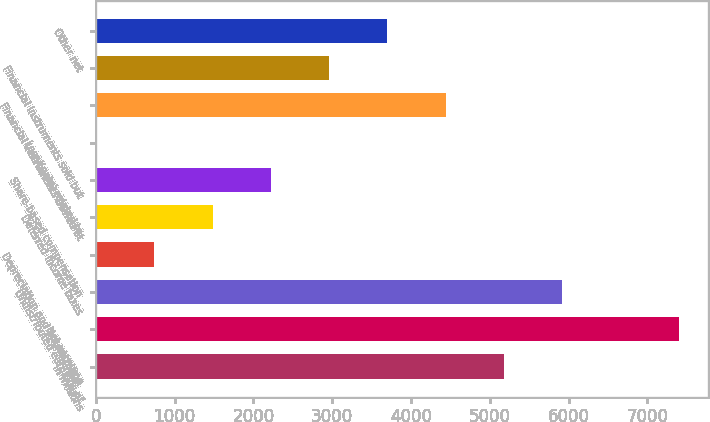Convert chart. <chart><loc_0><loc_0><loc_500><loc_500><bar_chart><fcel>in millions<fcel>Net earnings<fcel>Undistributed earnings of<fcel>Depreciation and amortization<fcel>Deferred income taxes<fcel>Share-based compensation<fcel>Loss/(gain) related to<fcel>Financial instruments owned at<fcel>Financial instruments sold but<fcel>Other net<nl><fcel>5179.5<fcel>7398<fcel>5919<fcel>742.5<fcel>1482<fcel>2221.5<fcel>3<fcel>4440<fcel>2961<fcel>3700.5<nl></chart> 